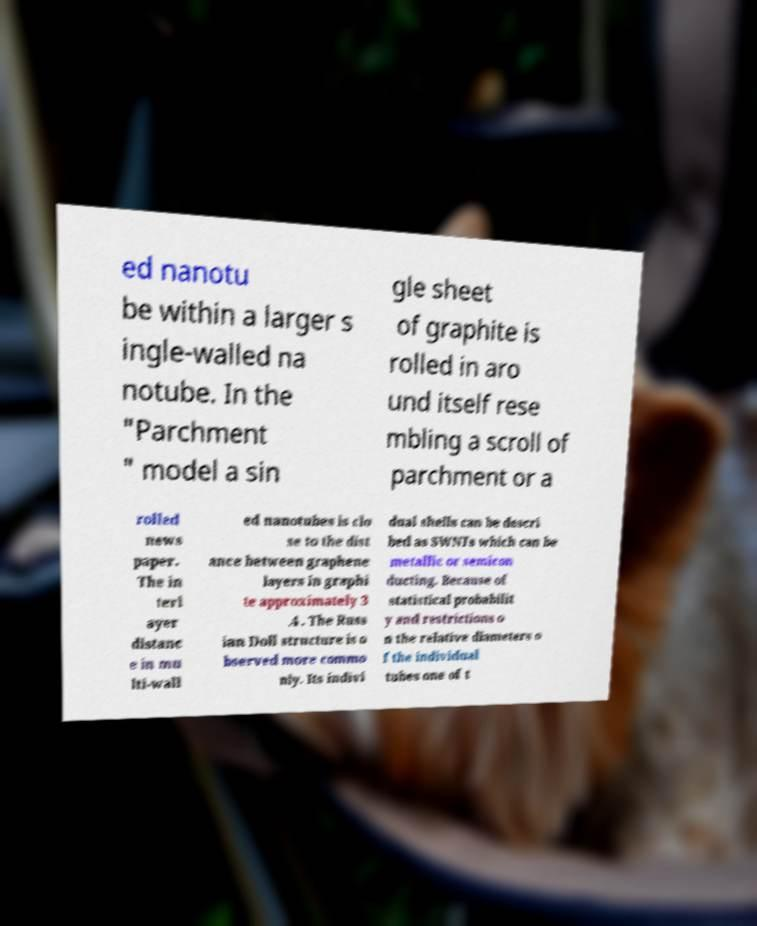I need the written content from this picture converted into text. Can you do that? ed nanotu be within a larger s ingle-walled na notube. In the "Parchment " model a sin gle sheet of graphite is rolled in aro und itself rese mbling a scroll of parchment or a rolled news paper. The in terl ayer distanc e in mu lti-wall ed nanotubes is clo se to the dist ance between graphene layers in graphi te approximately 3 .4 . The Russ ian Doll structure is o bserved more commo nly. Its indivi dual shells can be descri bed as SWNTs which can be metallic or semicon ducting. Because of statistical probabilit y and restrictions o n the relative diameters o f the individual tubes one of t 